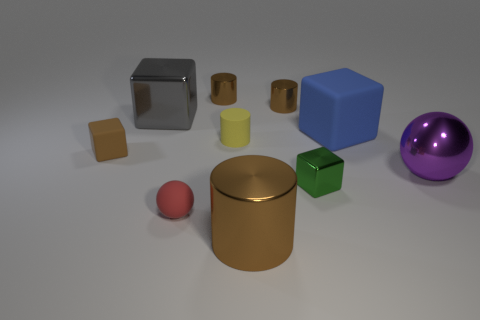There is a big shiny thing that is in front of the big purple shiny ball; is it the same shape as the small yellow matte thing?
Ensure brevity in your answer.  Yes. Are there any other things that are made of the same material as the blue thing?
Your response must be concise. Yes. How many objects are brown blocks or cylinders that are in front of the brown rubber thing?
Offer a very short reply. 2. There is a thing that is in front of the shiny ball and on the left side of the yellow object; what size is it?
Give a very brief answer. Small. Is the number of large metal things that are left of the rubber sphere greater than the number of small yellow things to the right of the large matte block?
Your response must be concise. Yes. Does the large purple shiny object have the same shape as the brown metallic object that is to the right of the big brown metallic cylinder?
Your answer should be compact. No. What number of other things are the same shape as the yellow thing?
Ensure brevity in your answer.  3. What is the color of the block that is both in front of the big rubber thing and to the right of the brown rubber block?
Your response must be concise. Green. What color is the large cylinder?
Keep it short and to the point. Brown. Is the material of the brown cube the same as the brown cylinder on the right side of the large brown metallic thing?
Give a very brief answer. No. 